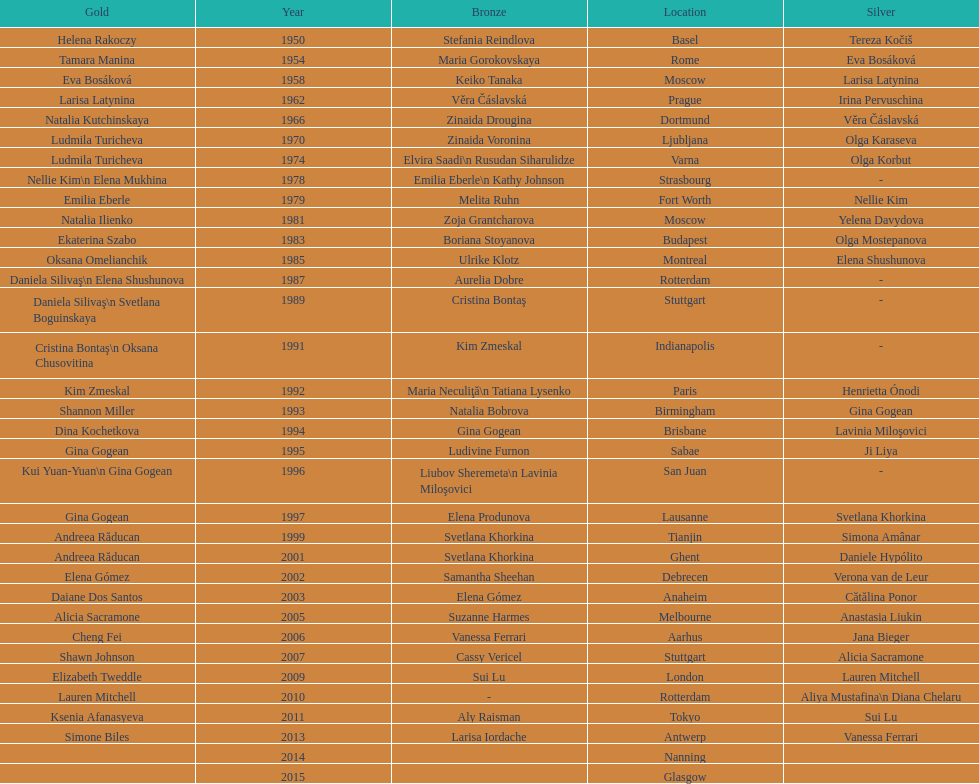Where were the championships held before the 1962 prague championships? Moscow. 